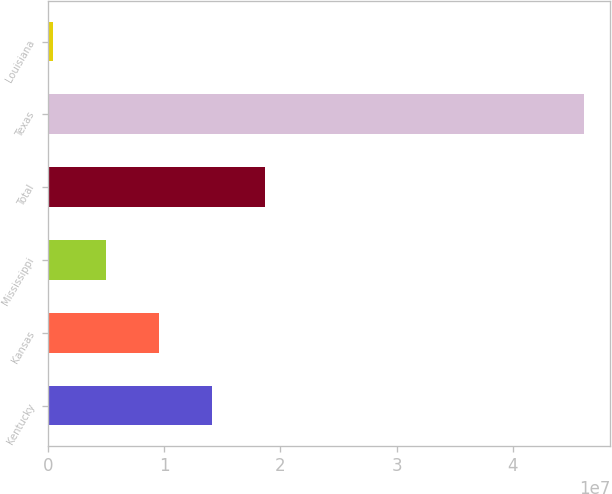Convert chart to OTSL. <chart><loc_0><loc_0><loc_500><loc_500><bar_chart><fcel>Kentucky<fcel>Kansas<fcel>Mississippi<fcel>Total<fcel>Texas<fcel>Louisiana<nl><fcel>1.41128e+07<fcel>9.54554e+06<fcel>4.97829e+06<fcel>1.868e+07<fcel>4.60835e+07<fcel>411040<nl></chart> 